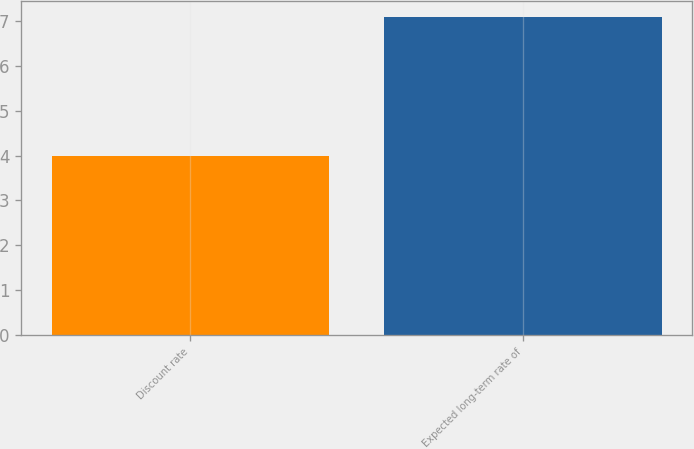Convert chart to OTSL. <chart><loc_0><loc_0><loc_500><loc_500><bar_chart><fcel>Discount rate<fcel>Expected long-term rate of<nl><fcel>4<fcel>7.1<nl></chart> 